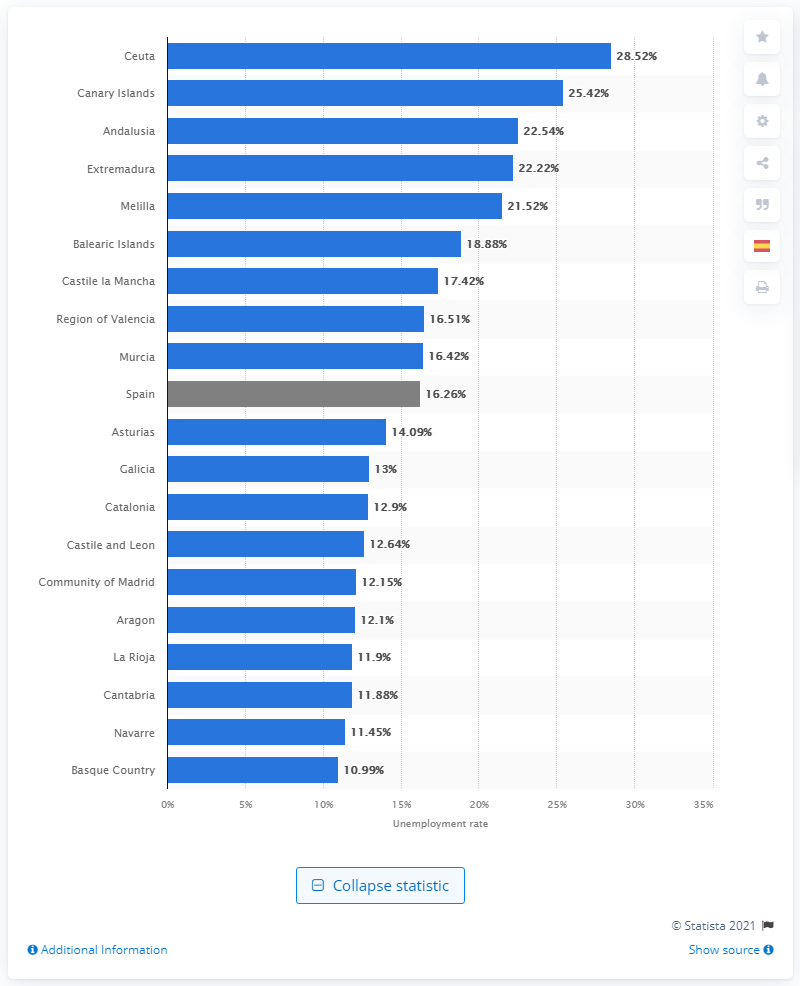What is the name of the southern region bordering Portugal?
 Extremadura 